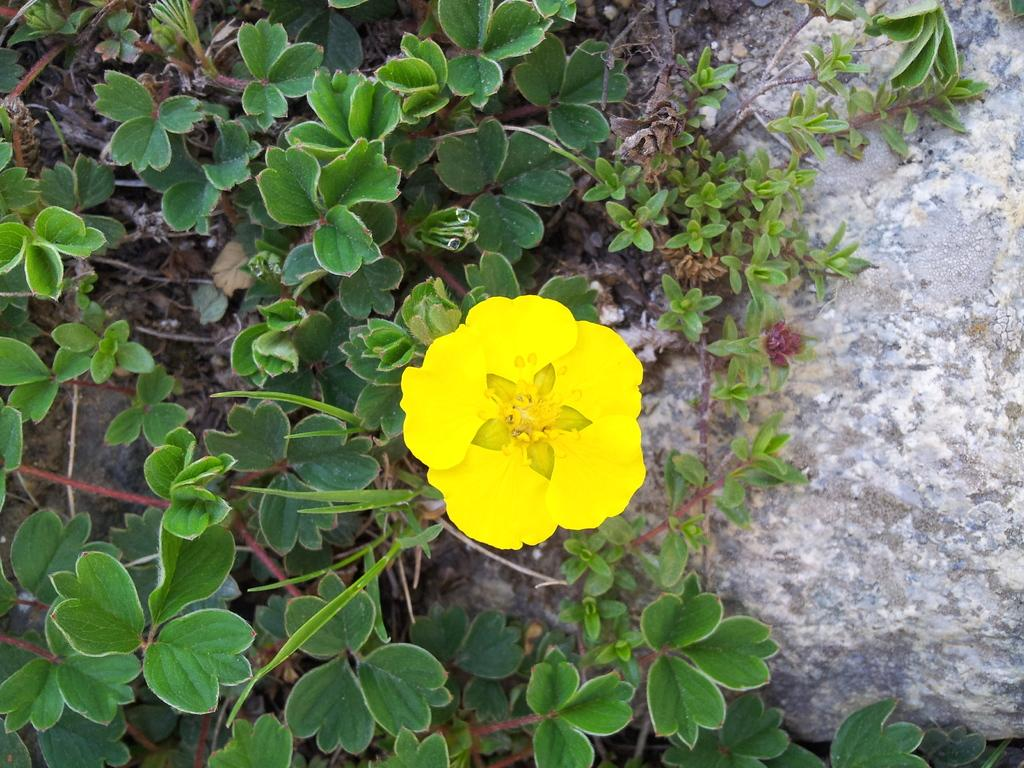What color is the flower in the image? The flower in the image is yellow. Where is the flower located? The flower is on a plant. What type of bone can be seen supporting the flower in the image? There is no bone present in the image; it features a yellow flower on a plant. How does the flower generate power in the image? The flower does not generate power in the image; it is a natural plant with no mechanical or electrical components. 